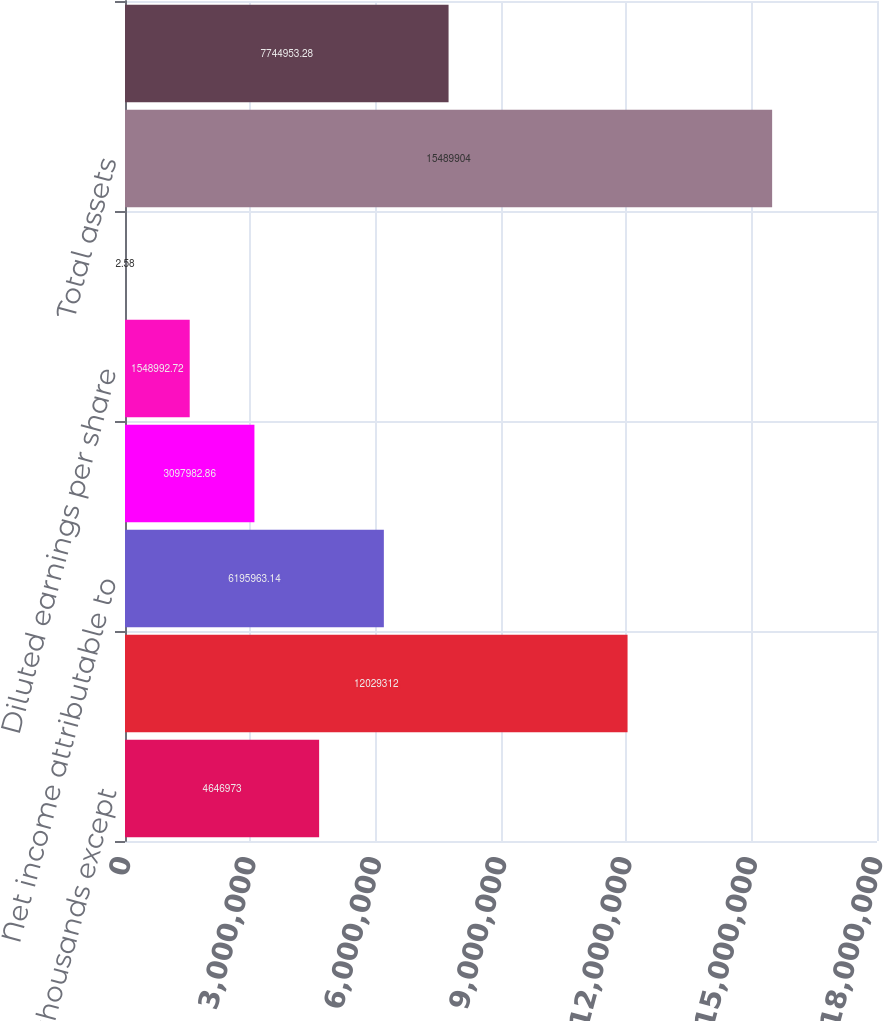Convert chart to OTSL. <chart><loc_0><loc_0><loc_500><loc_500><bar_chart><fcel>(Amounts in thousands except<fcel>Net sales<fcel>Net income attributable to<fcel>Basic earnings per share<fcel>Diluted earnings per share<fcel>Cash dividends per share<fcel>Total assets<fcel>Long-term debt<nl><fcel>4.64697e+06<fcel>1.20293e+07<fcel>6.19596e+06<fcel>3.09798e+06<fcel>1.54899e+06<fcel>2.58<fcel>1.54899e+07<fcel>7.74495e+06<nl></chart> 